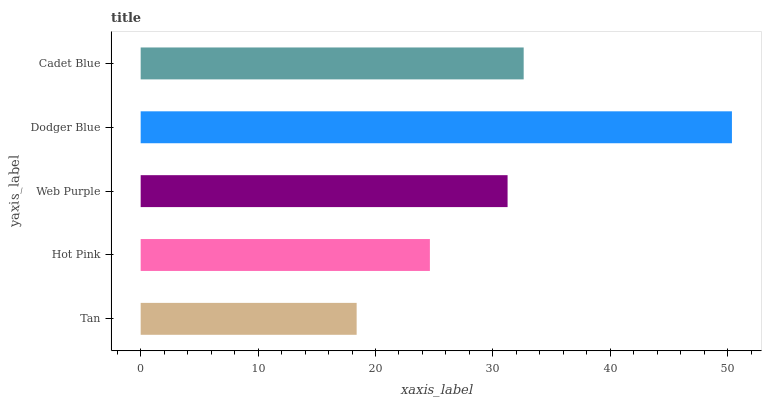Is Tan the minimum?
Answer yes or no. Yes. Is Dodger Blue the maximum?
Answer yes or no. Yes. Is Hot Pink the minimum?
Answer yes or no. No. Is Hot Pink the maximum?
Answer yes or no. No. Is Hot Pink greater than Tan?
Answer yes or no. Yes. Is Tan less than Hot Pink?
Answer yes or no. Yes. Is Tan greater than Hot Pink?
Answer yes or no. No. Is Hot Pink less than Tan?
Answer yes or no. No. Is Web Purple the high median?
Answer yes or no. Yes. Is Web Purple the low median?
Answer yes or no. Yes. Is Hot Pink the high median?
Answer yes or no. No. Is Hot Pink the low median?
Answer yes or no. No. 